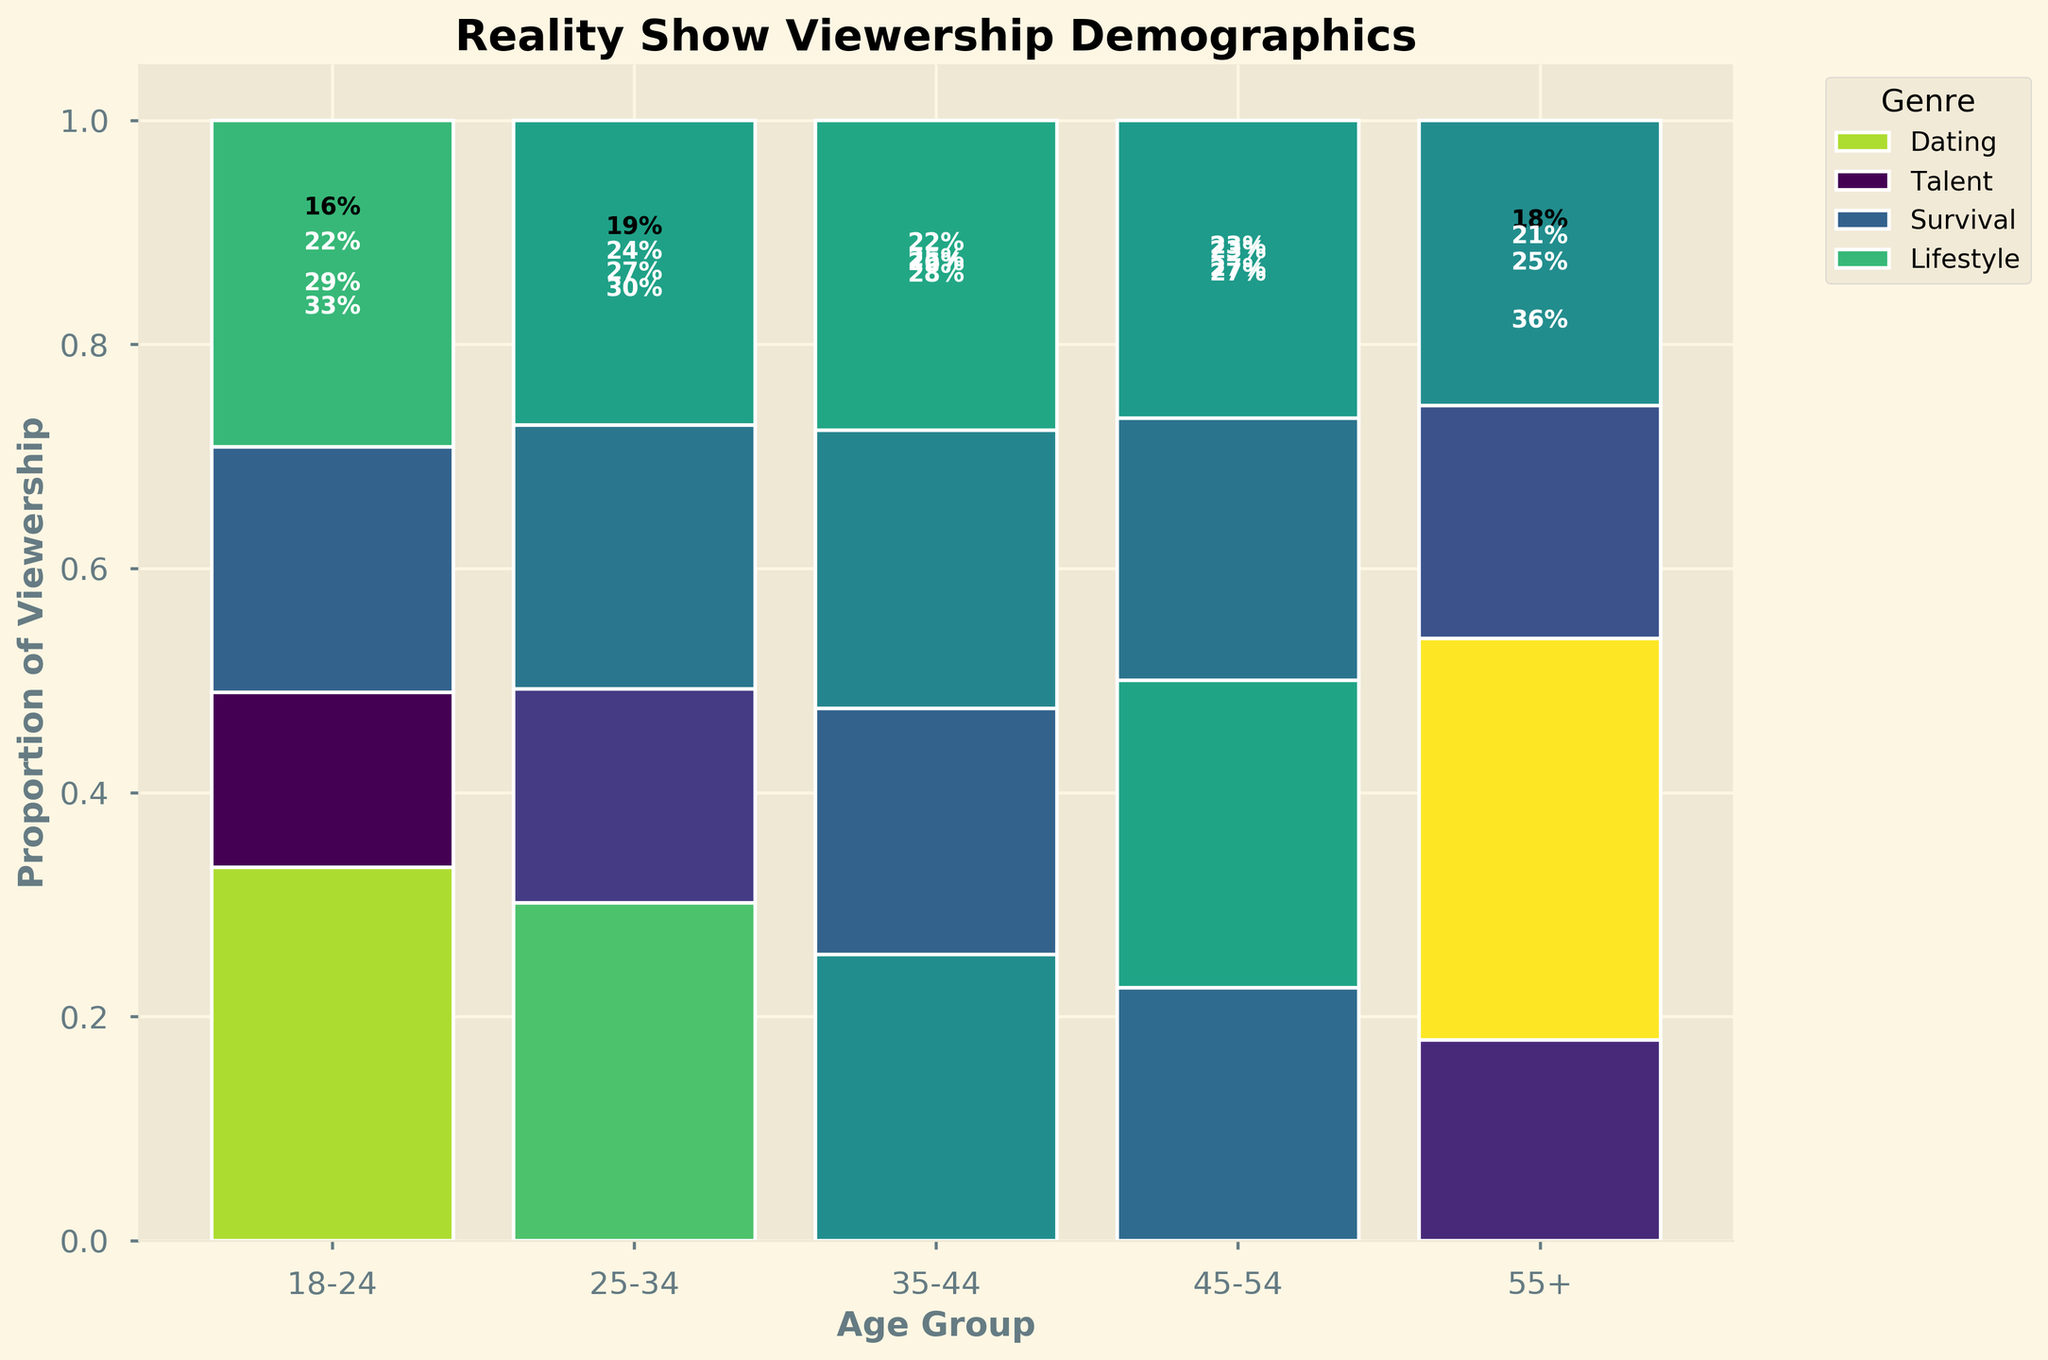What is the most popular genre among the 18-24 age group? The largest segment for the 18-24 age group is the Dating genre as shown by the largest portion of the bar.
Answer: Dating Which age group has the smallest viewership proportion for the Talent genre? For each age group, the proportion size for the Talent genre is compared. The 18-24 age group has the smallest segment for Talent.
Answer: 18-24 What is the combined proportion of viewership for Survival and Lifestyle genres in the 25-34 age group? The height of the segments for Survival and Lifestyle genres in the 25-34 age group are summed up. Survival is 0.27 and Lifestyle is 0.22, so the total is 0.27 + 0.22 = 0.49.
Answer: 0.49 Which genre has the most viewership proportion across all age groups? Sum the proportional heights for each genre across all age groups and compare. The Talent genre has the highest cumulative proportion.
Answer: Talent How does the viewership proportion of the Lifestyle genre in the 55+ age group compare to that in the 18-24 age group? Compare the height of the Lifestyle segments in both age groups. The Lifestyle genre has a significantly larger segment in the 55+ age group than in the 18-24 age group.
Answer: 55+ has a larger proportion In the age group of 35-44, is the proportion of viewership for the Survival genre greater than that of the Dating genre? Compare the heights of the segments for Survival and Dating in the 35-44 age group. The height for Survival is greater than that for Dating.
Answer: Yes What is the proportion difference between the Dating genre in the 45-54 and 55+ age groups? Calculate the difference in proportions: 45-54 (approx. 0.25) and 55+ (approx. 0.18). The difference is 0.25 - 0.18 = 0.07.
Answer: 0.07 